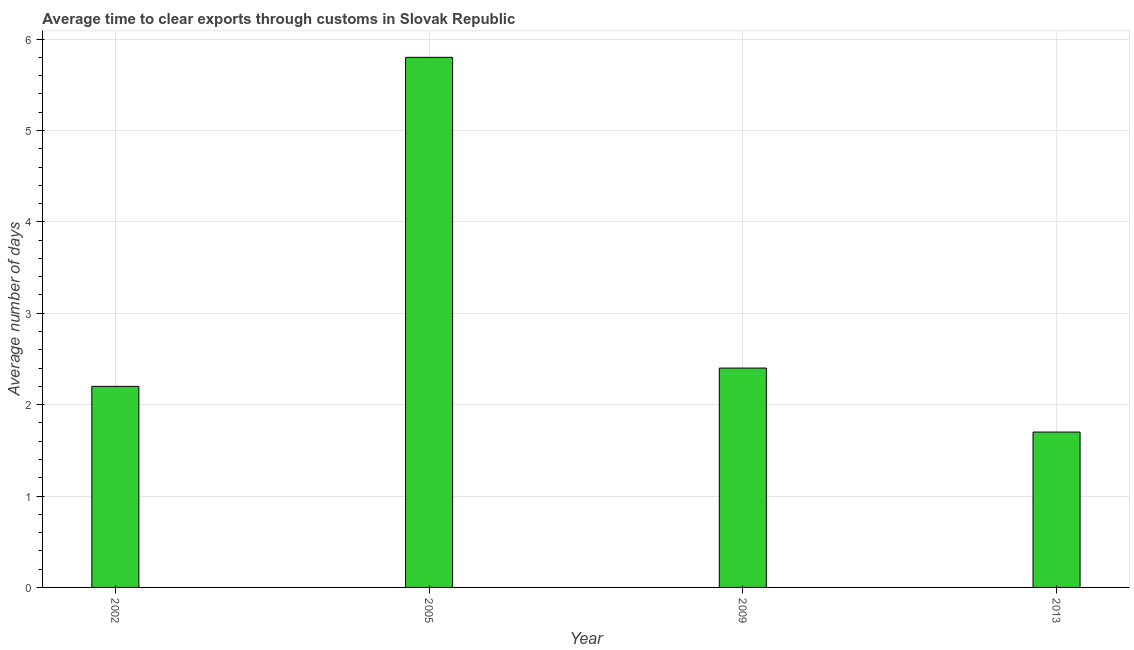Does the graph contain grids?
Your answer should be compact. Yes. What is the title of the graph?
Give a very brief answer. Average time to clear exports through customs in Slovak Republic. What is the label or title of the Y-axis?
Keep it short and to the point. Average number of days. What is the time to clear exports through customs in 2005?
Provide a succinct answer. 5.8. Across all years, what is the maximum time to clear exports through customs?
Offer a terse response. 5.8. In which year was the time to clear exports through customs maximum?
Provide a succinct answer. 2005. What is the sum of the time to clear exports through customs?
Provide a succinct answer. 12.1. What is the average time to clear exports through customs per year?
Offer a terse response. 3.02. What is the ratio of the time to clear exports through customs in 2002 to that in 2013?
Your response must be concise. 1.29. Is the time to clear exports through customs in 2009 less than that in 2013?
Provide a succinct answer. No. What is the difference between the highest and the lowest time to clear exports through customs?
Offer a terse response. 4.1. In how many years, is the time to clear exports through customs greater than the average time to clear exports through customs taken over all years?
Make the answer very short. 1. How many bars are there?
Offer a very short reply. 4. Are the values on the major ticks of Y-axis written in scientific E-notation?
Provide a succinct answer. No. What is the difference between the Average number of days in 2002 and 2005?
Ensure brevity in your answer.  -3.6. What is the difference between the Average number of days in 2002 and 2013?
Your response must be concise. 0.5. What is the difference between the Average number of days in 2009 and 2013?
Provide a succinct answer. 0.7. What is the ratio of the Average number of days in 2002 to that in 2005?
Your response must be concise. 0.38. What is the ratio of the Average number of days in 2002 to that in 2009?
Keep it short and to the point. 0.92. What is the ratio of the Average number of days in 2002 to that in 2013?
Your answer should be very brief. 1.29. What is the ratio of the Average number of days in 2005 to that in 2009?
Make the answer very short. 2.42. What is the ratio of the Average number of days in 2005 to that in 2013?
Keep it short and to the point. 3.41. What is the ratio of the Average number of days in 2009 to that in 2013?
Offer a terse response. 1.41. 